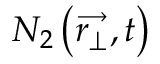Convert formula to latex. <formula><loc_0><loc_0><loc_500><loc_500>N _ { 2 } \left ( \overrightarrow { r _ { \perp } } , t \right )</formula> 